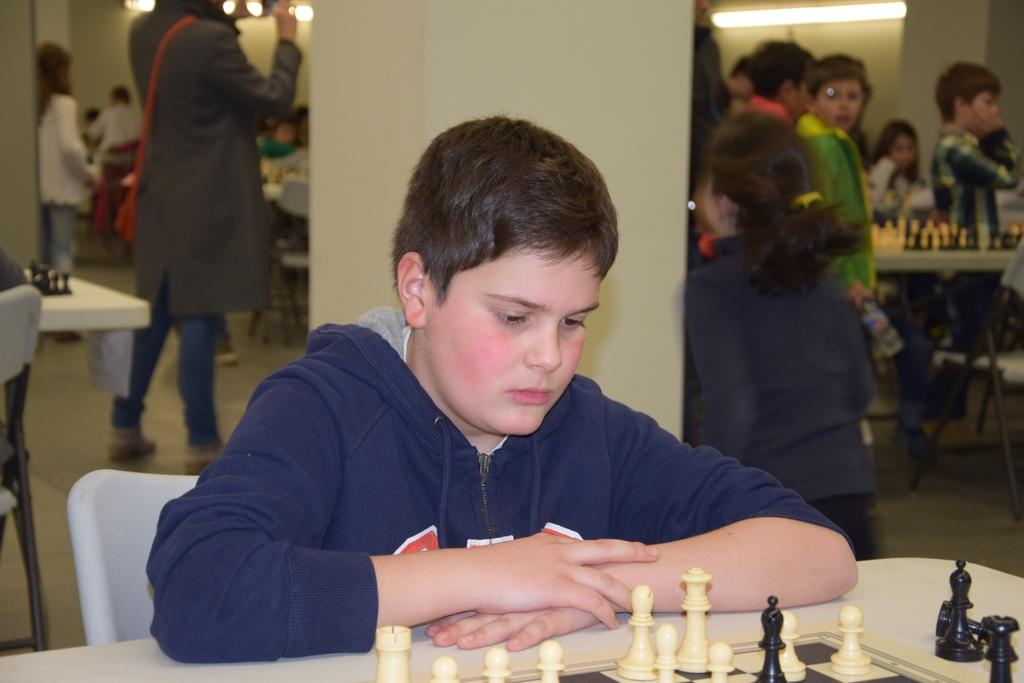Who is the main subject in the image? There is a boy in the image. What is the boy doing in the image? The boy is playing chess. Can you describe the setting of the image? There are people in the background of the image. What type of tray is the boy using to hold the chess pieces in the image? There is no tray present in the image; the boy is playing chess without a tray. Can you describe the coil that is wrapped around the boy's arm in the image? There is no coil wrapped around the boy's arm in the image; he is simply playing chess. 